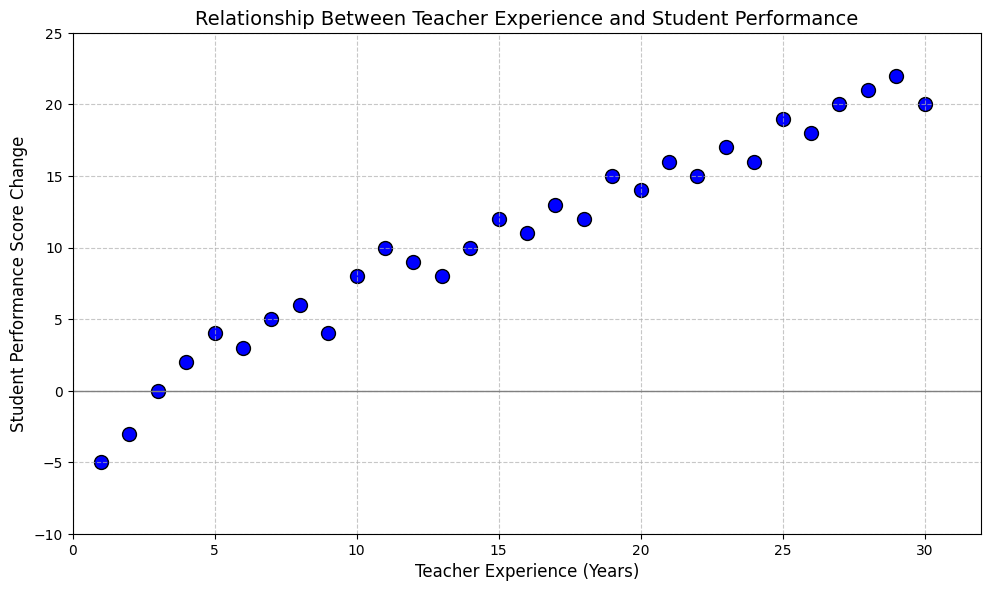What's the general trend seen in the relationship between teacher experience and student performance score change? The data points generally show that as the number of years of teacher experience increases, there is an upward trend in the student performance score change. Most data points with higher years of teacher experience correspond to higher performance score changes.
Answer: Positive trend What is the performance score change for teachers with 10 years of experience? Locate the data point corresponding to 10 years on the x-axis and find the y-value. The plot shows a performance score change of approximately 8.
Answer: 8 How many teachers have negative performance score changes, and what does this signify? By counting the datapoints below the y=0 line (where score change is negative), there are 3 such points (at 1, 2, and 3 years). This signifies that early in their careers, some teachers see a drop in student performance.
Answer: 3 teachers Compare the highest and lowest student performance score changes in terms of teacher experience years. What do you observe? The highest performance score change is 22 at 29 years of experience, and the lowest is -5 at 1 year of experience. Thus, the longer the experience, the better the performance score change tends to be.
Answer: More experience, better performance What is the average performance score change for teachers with 1 to 5 years of experience? Performance changes are -5, -3, 0, 2, and 4 for 1 to 5 years respectively. Sum these values (-5 + -3 + 0 + 2 + 4) to get -2, then divide by 5 to obtain an average of -0.4
Answer: -0.4 How many data points signify a performance score change of 10 or more? By counting the data points at or above the 10 mark on the y-axis, there are 7 (11, 14, 15, 17, 20, 21, and 22).
Answer: 7 What is the median performance score change for teachers with 10 to 15 years of experience? The performance changes for 10, 11, 12, 13, 14, and 15 years are: 8, 10, 9, 8, 10, and 12. Sorting these values: 8, 8, 9, 10, 10, 12. The median, or middle value(s), are 9 and 10. Hence, the median value is (9+10)/2 = 9.5.
Answer: 9.5 What conclusion can we draw about teacher experience and student performance based on the scatter plot? The general trend shows that more experienced teachers tend to have higher positive impacts on student performance. The plot illustrates this by showing increasing performance scores as experience increases. **Note: This is an interpretative question contingent on visual trends only.**
Answer: More experience, better student performance Is there a maximum performance score change, and which teacher experience year does it correspond to? The maximum performance score change is 22, which corresponds to a teacher experience of 29 years.
Answer: 22 at 29 years 